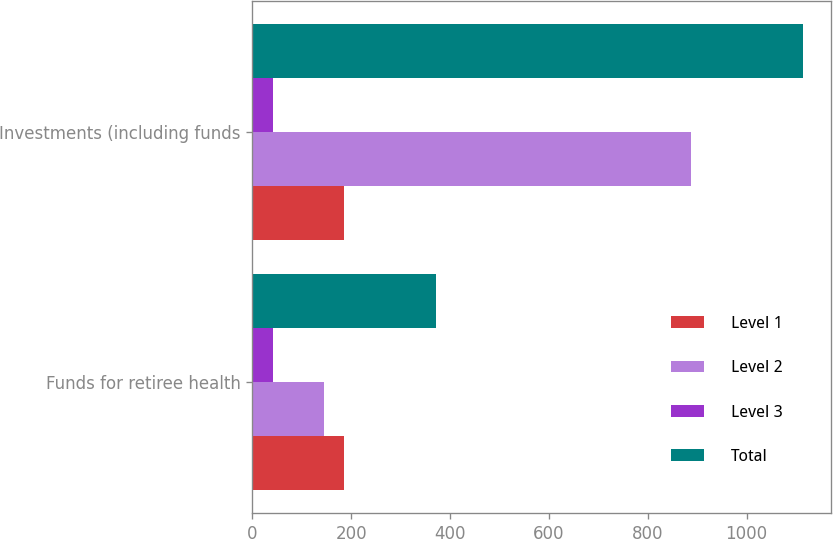<chart> <loc_0><loc_0><loc_500><loc_500><stacked_bar_chart><ecel><fcel>Funds for retiree health<fcel>Investments (including funds<nl><fcel>Level 1<fcel>185<fcel>185<nl><fcel>Level 2<fcel>145<fcel>888<nl><fcel>Level 3<fcel>42<fcel>42<nl><fcel>Total<fcel>372<fcel>1115<nl></chart> 